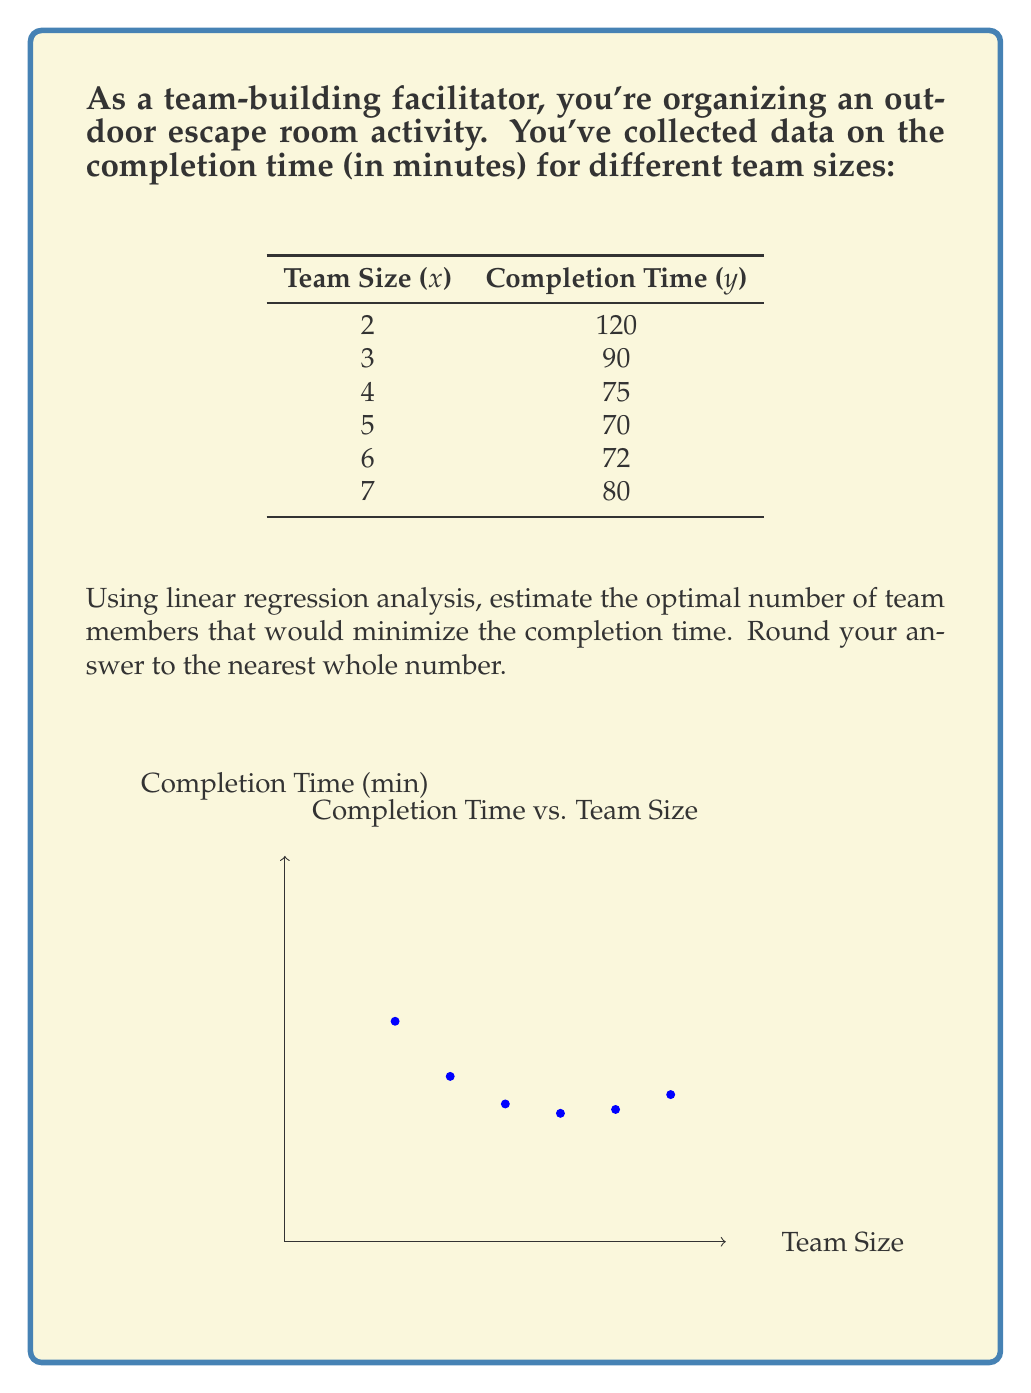Show me your answer to this math problem. To solve this problem, we'll use quadratic regression to fit a parabola to the data points. The steps are as follows:

1) First, we need to find the quadratic equation in the form $y = ax^2 + bx + c$ that best fits the data.

2) Using a calculator or computer software, we can determine the coefficients:
   $a = 2.6786$, $b = -29.7857$, $c = 151.7143$

3) The quadratic equation is:
   $y = 2.6786x^2 - 29.7857x + 151.7143$

4) To find the minimum point of this parabola (which represents the optimal team size), we need to find the x-coordinate of the vertex. The formula for this is $x = -\frac{b}{2a}$

5) Substituting our values:
   $x = -\frac{-29.7857}{2(2.6786)} = 5.5595$

6) Rounding to the nearest whole number:
   Optimal team size ≈ 6

Therefore, the estimated optimal number of team members that would minimize the completion time is 6.
Answer: 6 team members 